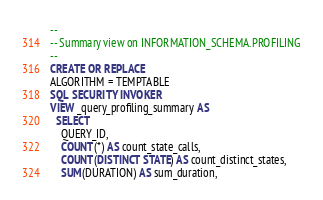Convert code to text. <code><loc_0><loc_0><loc_500><loc_500><_SQL_>-- 
-- Summary view on INFORMATION_SCHEMA.PROFILING
-- 
CREATE OR REPLACE
ALGORITHM = TEMPTABLE
SQL SECURITY INVOKER
VIEW _query_profiling_summary AS
  SELECT 
    QUERY_ID,
    COUNT(*) AS count_state_calls,
    COUNT(DISTINCT STATE) AS count_distinct_states,
    SUM(DURATION) AS sum_duration,</code> 